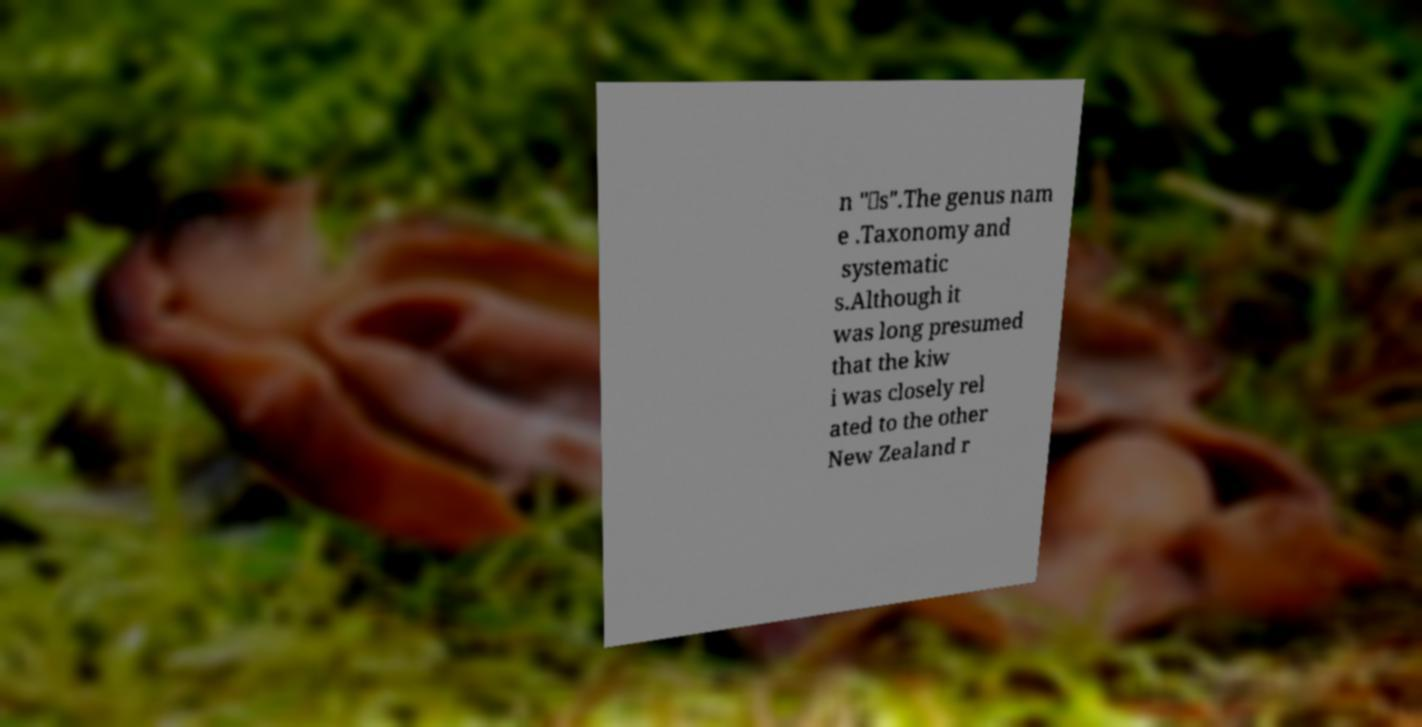Can you accurately transcribe the text from the provided image for me? n "‑s".The genus nam e .Taxonomy and systematic s.Although it was long presumed that the kiw i was closely rel ated to the other New Zealand r 